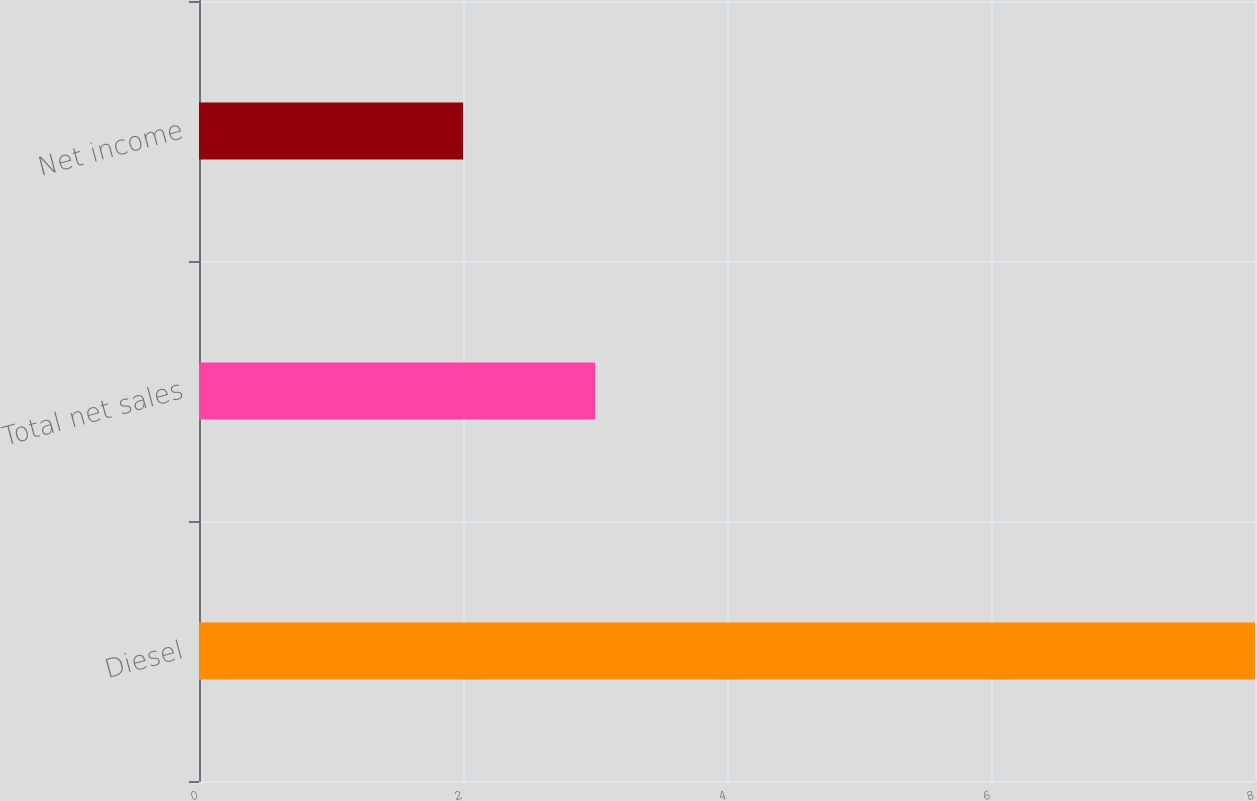Convert chart. <chart><loc_0><loc_0><loc_500><loc_500><bar_chart><fcel>Diesel<fcel>Total net sales<fcel>Net income<nl><fcel>8<fcel>3<fcel>2<nl></chart> 